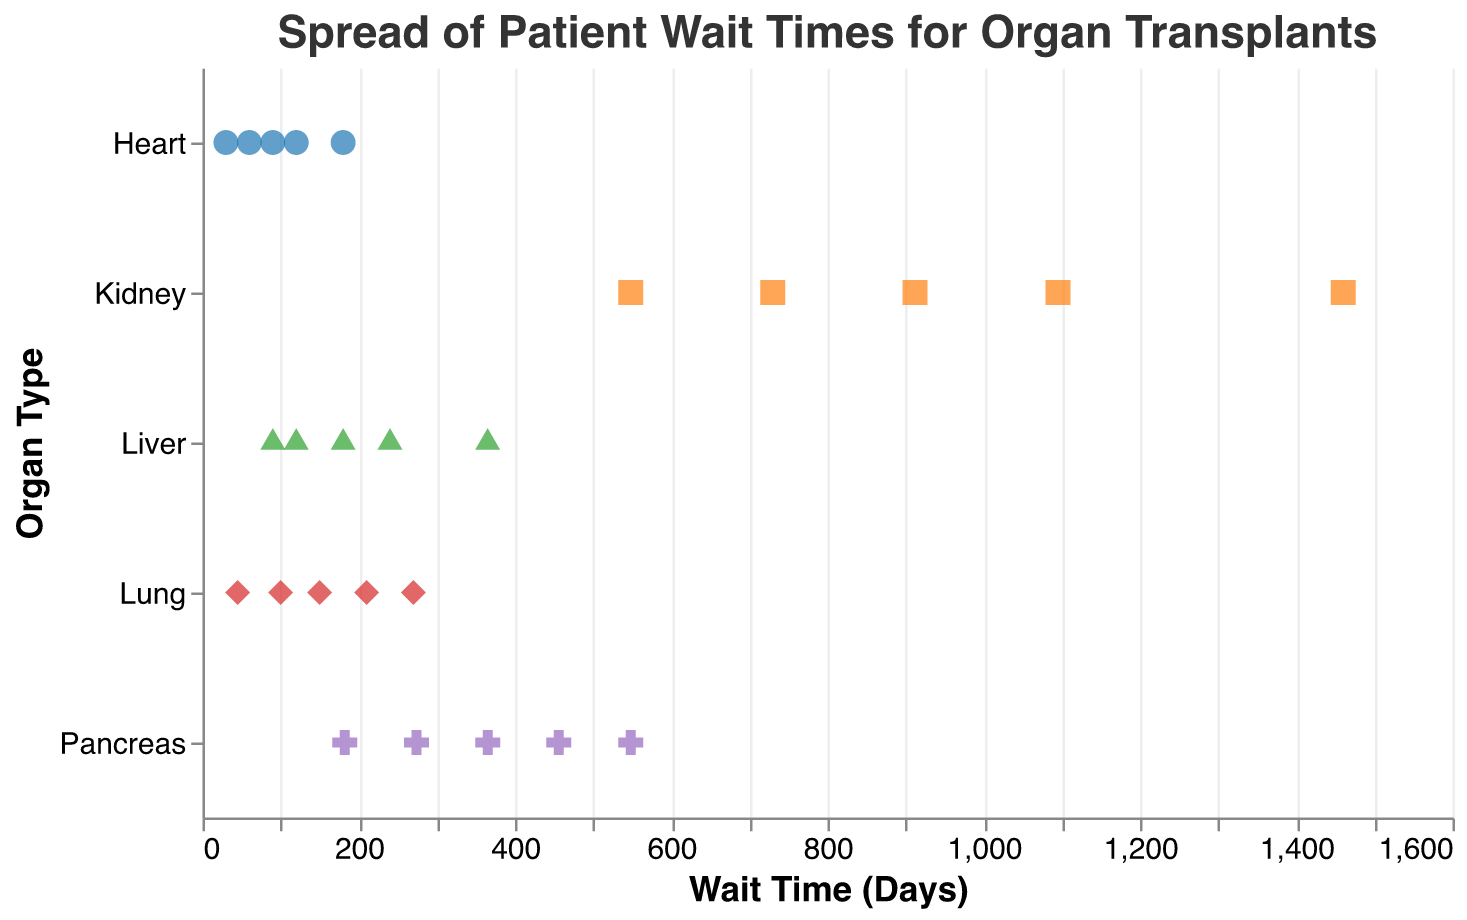What is the title of the figure? The title is prominently displayed at the top of the chart.
Answer: Spread of Patient Wait Times for Organ Transplants How many kidney transplant wait times are represented in the plot? Counting the number of points in the "Kidney" row, there are 5 points.
Answer: 5 Which organ type has the shortest wait time across all data points? Observing the x-axis values and the position of the points, the shortest wait time is for a Heart at 30 days.
Answer: Heart What is the range of wait times for liver transplants? Identifying the minimum wait time (90 days) and the maximum wait time (365 days), the range is 365 - 90 = 275 days.
Answer: 275 days Do any two organ types share the same maximum wait time, and if so, which ones? Comparing the maximum wait times for each organ type, both Kidney and Liver have the longest wait time of 1460 and 365 days respectively. But no two organ types share the same exact wait time.
Answer: No What is the average wait time for pancreas transplants? Summing the wait times for pancreas: 365 + 548 + 274 + 456 + 182 = 1825, then dividing by the number of points (5), the average is 1825 / 5 = 365 days.
Answer: 365 days Which organ type shows the least variation in wait times? Comparing the spread of points horizontally, the Heart has the smallest spread between the shortest (30 days) and the longest (180 days) wait time.
Answer: Heart How does the wait time for kidney transplants compare to that for lung transplants? Kidney wait times range from 548 to 1460 days, and lung wait times range from 45 to 270 days. Kidney wait times are generally longer than lung wait times.
Answer: Kidney wait times are longer What organ type has the most clustered wait times, indicating less variability between patients? Observing the clustering of points, Liver wait times appear to be the most clustered around a couple of specific values such as 120, 180, and 240 days.
Answer: Liver Do any organ types have overlapping wait times among their data points? Analyzing the points: Kidney (548, 730, 912, 1095, 1460 days) and Pancreas (182, 274, 365, 456, 548 days) both have overlapping wait times at 548 days.
Answer: Kidney and Pancreas 